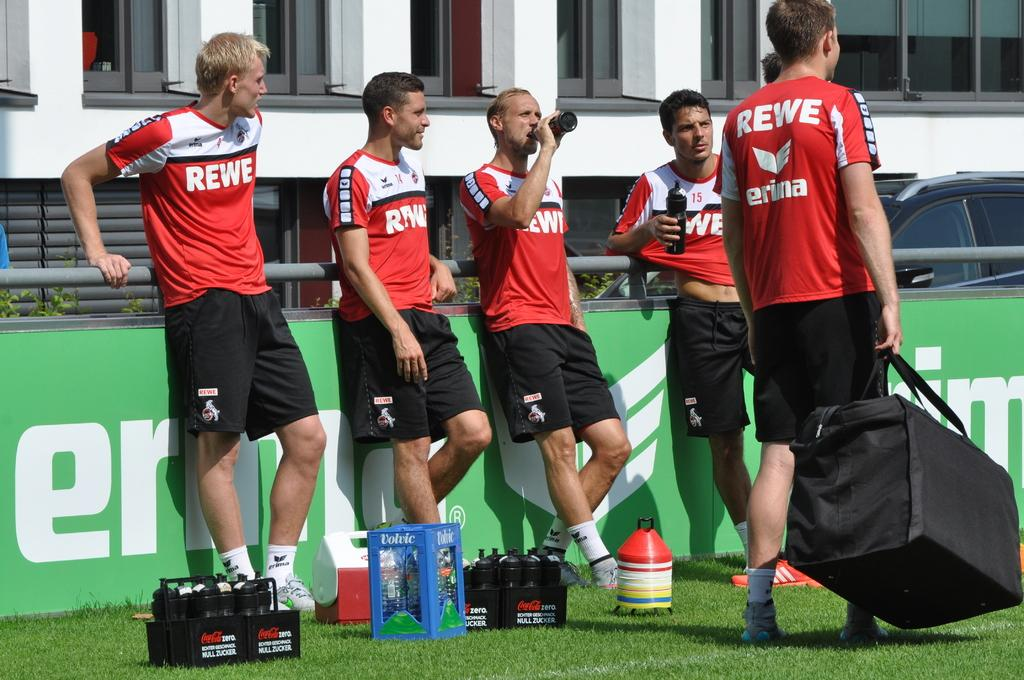<image>
Provide a brief description of the given image. Four footballers wearing red tops with REWE written on them take a break as a kit man walks by. 